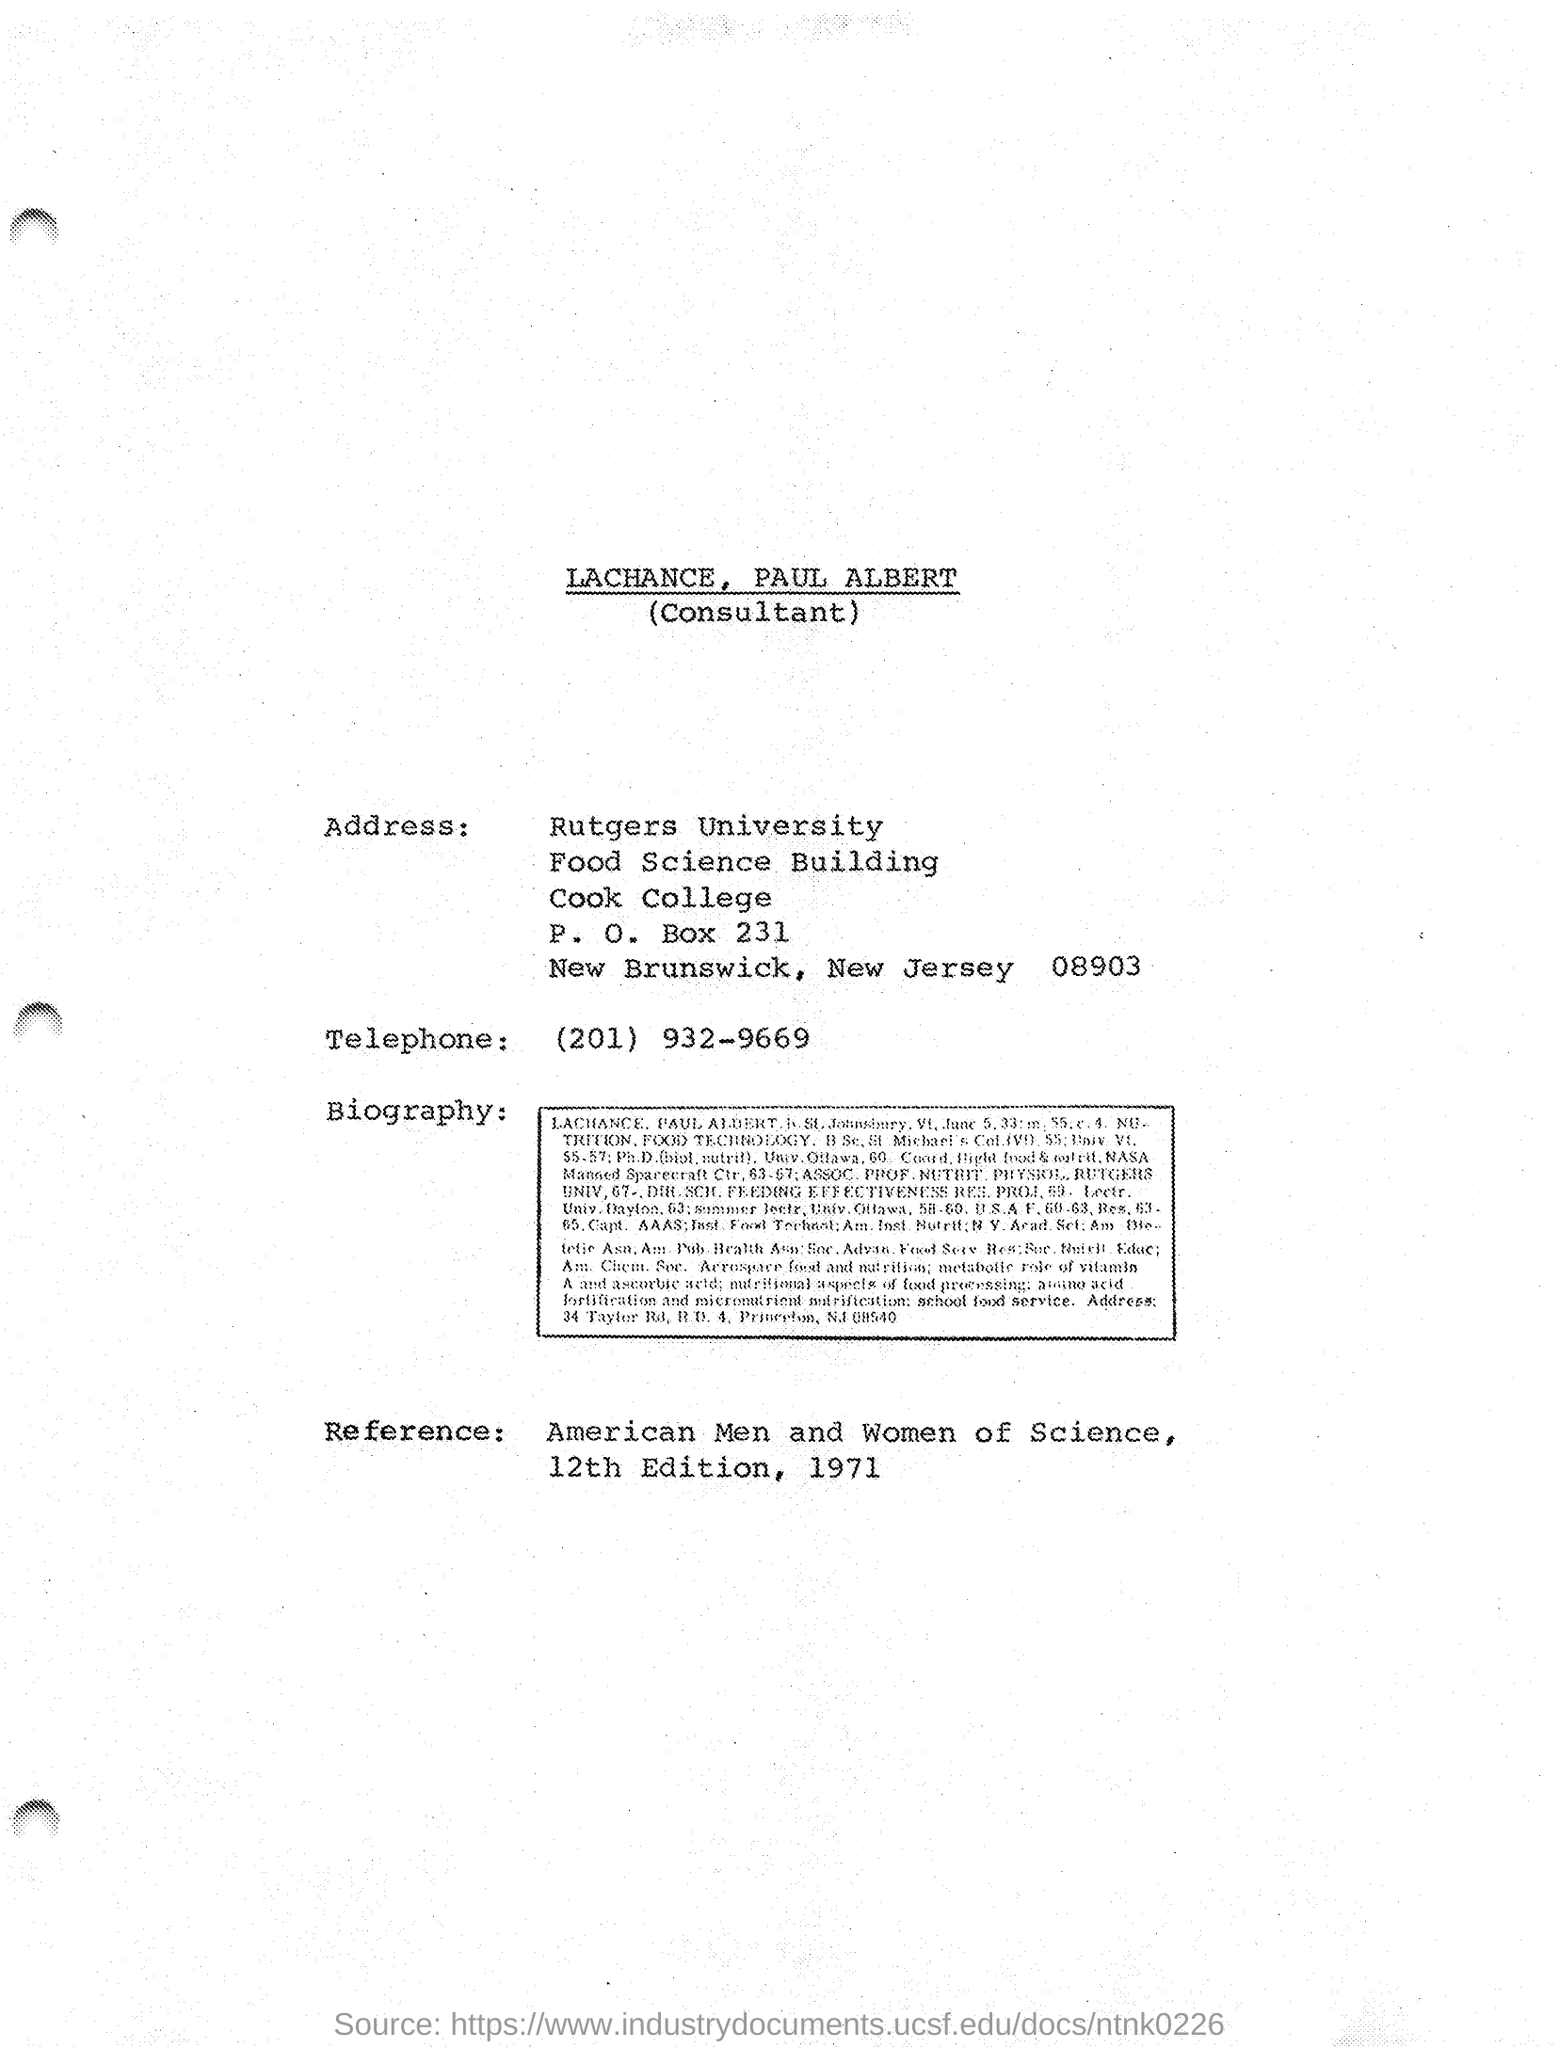Who is the consultant mentioned in this document?
Your response must be concise. LACHANCE, PAUL ALBERT. What is the P.O.Box no given in the document?
Offer a very short reply. 231. What is the Telephone No mentioned in this document?
Make the answer very short. (201) 932-9669. What is the Reference given in this document?
Provide a succinct answer. American Men and Women of Science, 12th Edition, 1971. 